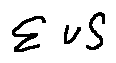<formula> <loc_0><loc_0><loc_500><loc_500>\sum v S</formula> 